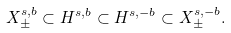Convert formula to latex. <formula><loc_0><loc_0><loc_500><loc_500>X ^ { s , b } _ { \pm } \subset H ^ { s , b } \subset H ^ { s , - b } \subset X ^ { s , - b } _ { \pm } .</formula> 